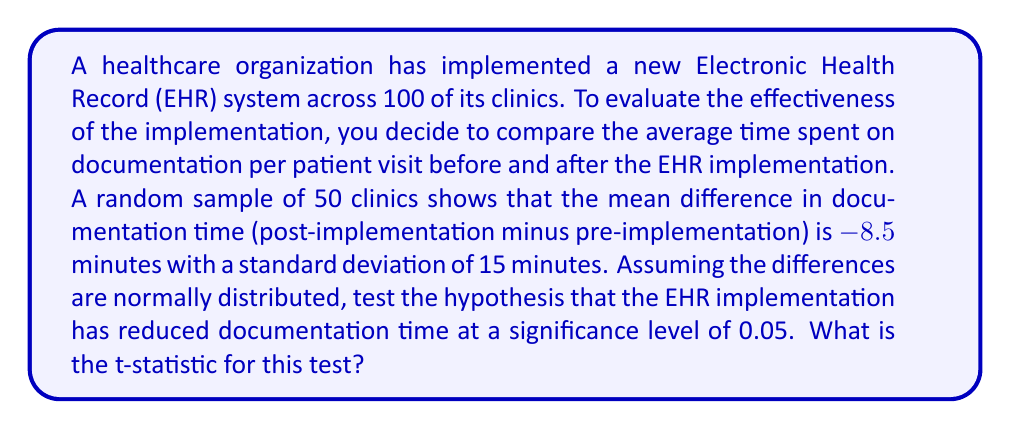Help me with this question. To test whether the EHR implementation has reduced documentation time, we need to perform a one-tailed t-test. We'll use the following steps:

1. State the null and alternative hypotheses:
   $H_0: \mu_d \geq 0$ (EHR implementation did not reduce documentation time)
   $H_a: \mu_d < 0$ (EHR implementation reduced documentation time)

   Where $\mu_d$ is the population mean difference in documentation time.

2. Calculate the t-statistic using the formula:

   $$t = \frac{\bar{x} - \mu_0}{s / \sqrt{n}}$$

   Where:
   $\bar{x}$ = sample mean difference = -8.5 minutes
   $\mu_0$ = hypothesized population mean difference under $H_0$ = 0 minutes
   $s$ = sample standard deviation = 15 minutes
   $n$ = sample size = 50

3. Plug in the values:

   $$t = \frac{-8.5 - 0}{15 / \sqrt{50}}$$

4. Simplify:

   $$t = \frac{-8.5}{15 / \sqrt{50}} = \frac{-8.5}{15 / 7.071} = \frac{-8.5}{2.121}$$

5. Calculate the final result:

   $$t = -4.007$$

The negative t-statistic indicates that the sample mean is below the hypothesized mean, which is consistent with our alternative hypothesis that the EHR implementation reduced documentation time.
Answer: $t = -4.007$ 